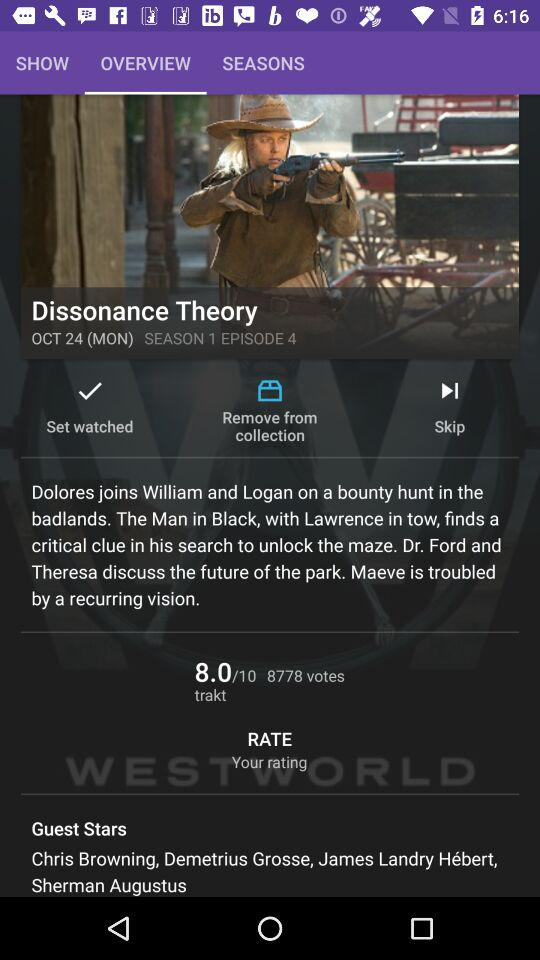Which tab am I on? You are on the "OVERVIEW" tab. 